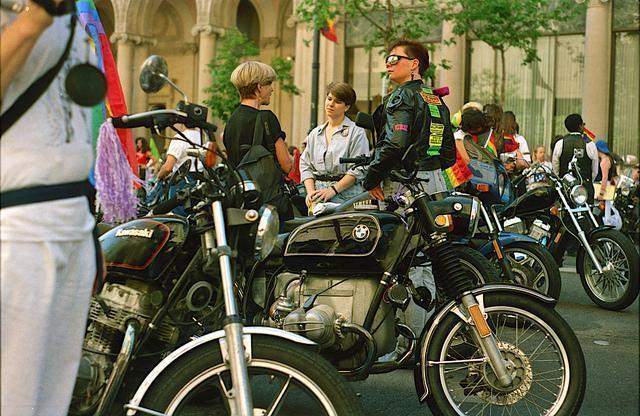What type of biking event is being held here?
Choose the right answer from the provided options to respond to the question.
Options: Hetrosexual, sit in, bake sale, gay. Gay. 